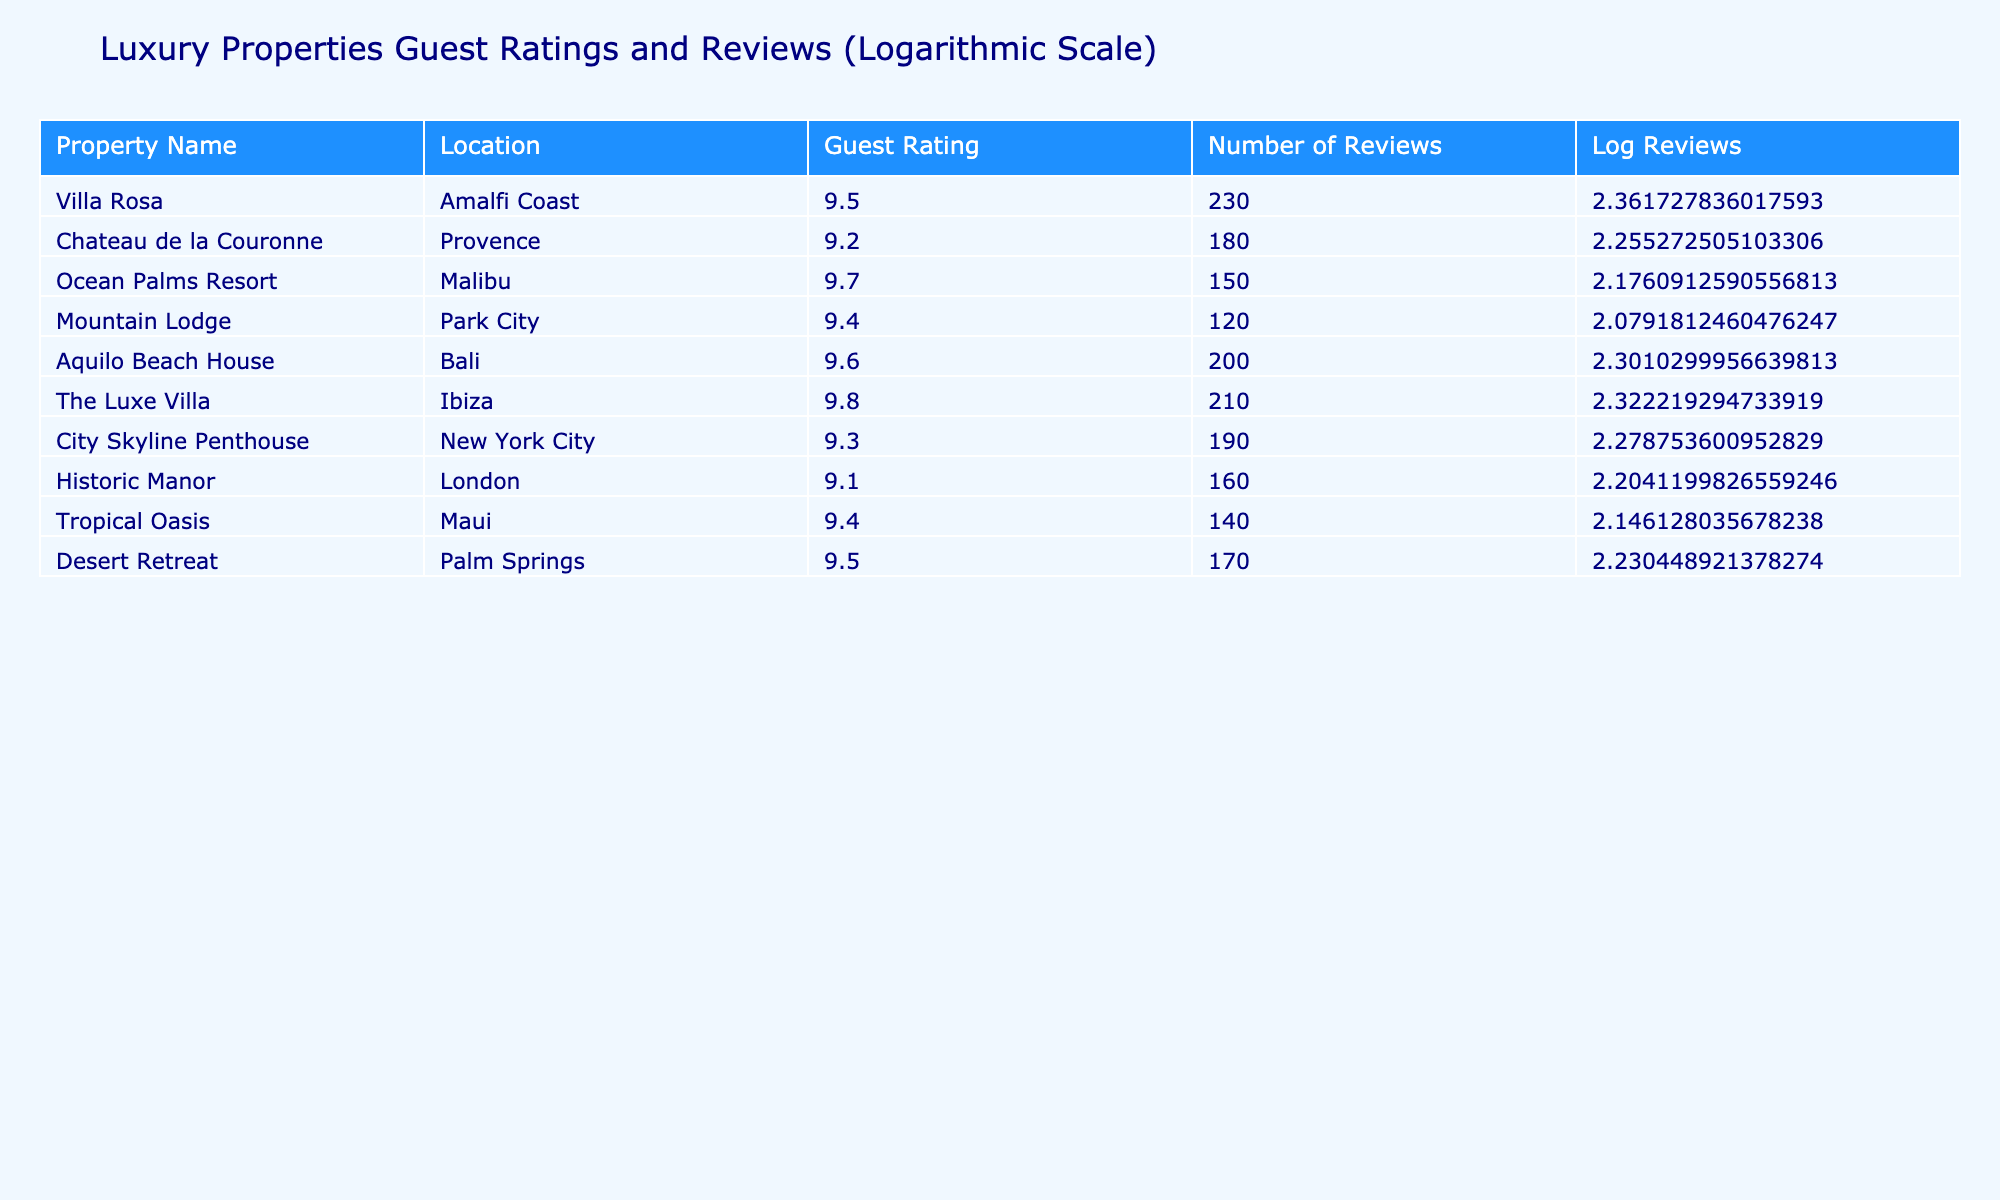What is the guest rating for the Ocean Palms Resort? The table lists the guest ratings for each property. The Ocean Palms Resort is explicitly stated as having a guest rating of 9.7.
Answer: 9.7 Which property has the highest number of reviews, and how many reviews does it have? The table provides the number of reviews for each property. By comparing the numbers, Villa Rosa has the highest number of reviews with a total of 230.
Answer: Villa Rosa, 230 Is the guest rating for the Historic Manor above 9? According to the table, the Historic Manor has a guest rating of 9.1, which is indeed above 9.
Answer: Yes What is the average guest rating for properties in Bali and Maui combined? The guest ratings for Aquilo Beach House in Bali is 9.6 and for Tropical Oasis in Maui is 9.4. To find the average, we add both ratings (9.6 + 9.4 = 19) and divide by 2, giving us an average of 9.5.
Answer: 9.5 How many properties have a guest rating of 9.5 or higher? The properties that meet this criterion are Villa Rosa (9.5), Ocean Palms Resort (9.7), Aquilo Beach House (9.6), The Luxe Villa (9.8), Desert Retreat (9.5). Counting these, there are 5 properties with a guest rating of 9.5 or higher.
Answer: 5 What is the difference in guest ratings between the highest-rated and the lowest-rated properties? The highest-rated property is The Luxe Villa with a rating of 9.8, and the lowest-rated property is Historic Manor with a rating of 9.1. The difference is calculated as 9.8 - 9.1 = 0.7.
Answer: 0.7 Does the City Skyline Penthouse have more or less than 200 reviews? The table states that City Skyline Penthouse has 190 reviews, which is less than 200.
Answer: Less What is the sum of guest ratings for all properties located in the Amalfi Coast and New York City? The guest rating for Villa Rosa in Amalfi Coast is 9.5, and City Skyline Penthouse in New York City has 9.3. Adding these gives us a total of 9.5 + 9.3 = 18.8.
Answer: 18.8 